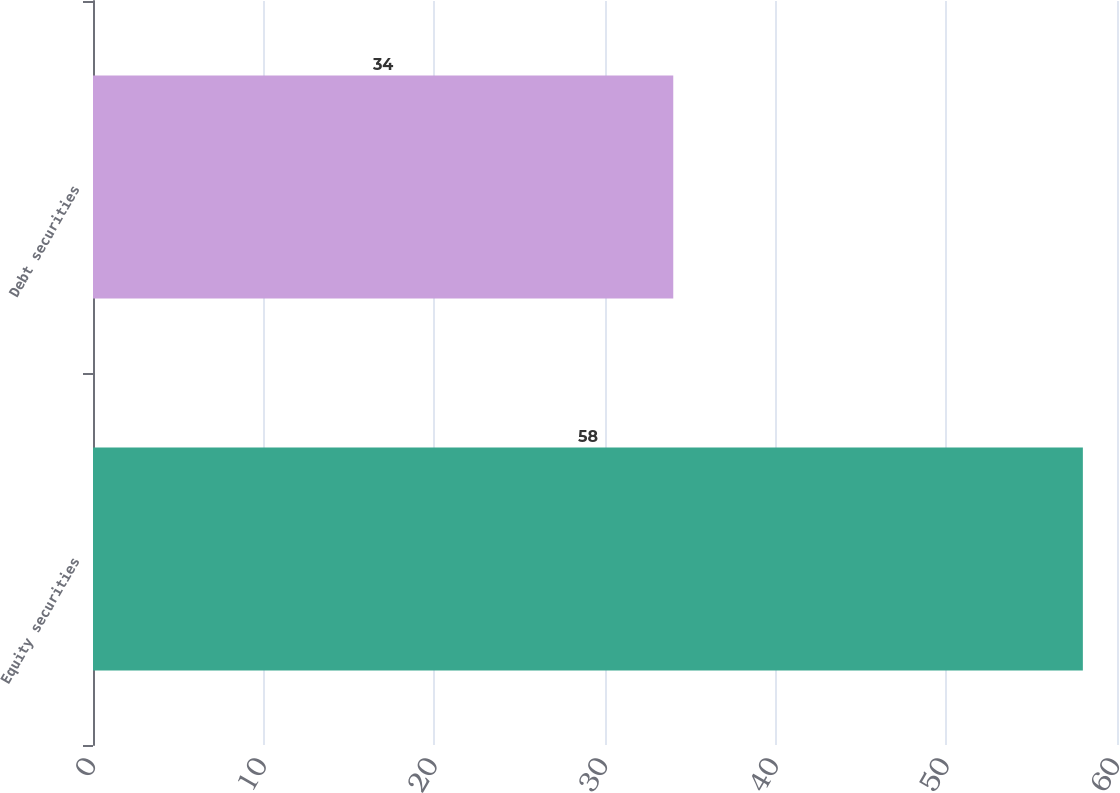Convert chart to OTSL. <chart><loc_0><loc_0><loc_500><loc_500><bar_chart><fcel>Equity securities<fcel>Debt securities<nl><fcel>58<fcel>34<nl></chart> 